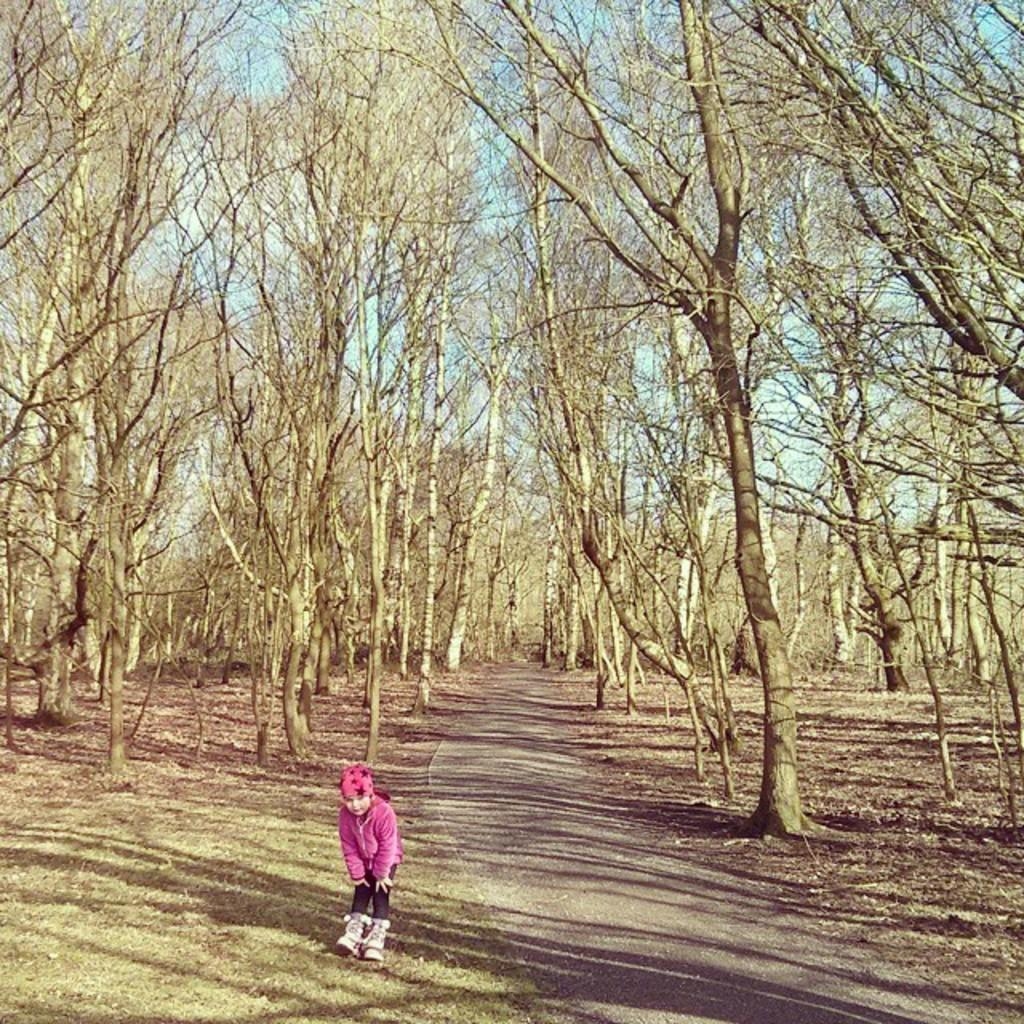What is the main subject of the image? There is a child in the image. What is the child's position in the image? The child is standing on the ground. What can be seen in the background of the image? There are trees, grass, a road, and the sky visible in the background of the image. What type of sweater is the child wearing at the seashore in the image? There is no seashore present in the image, and the child is not wearing a sweater. 